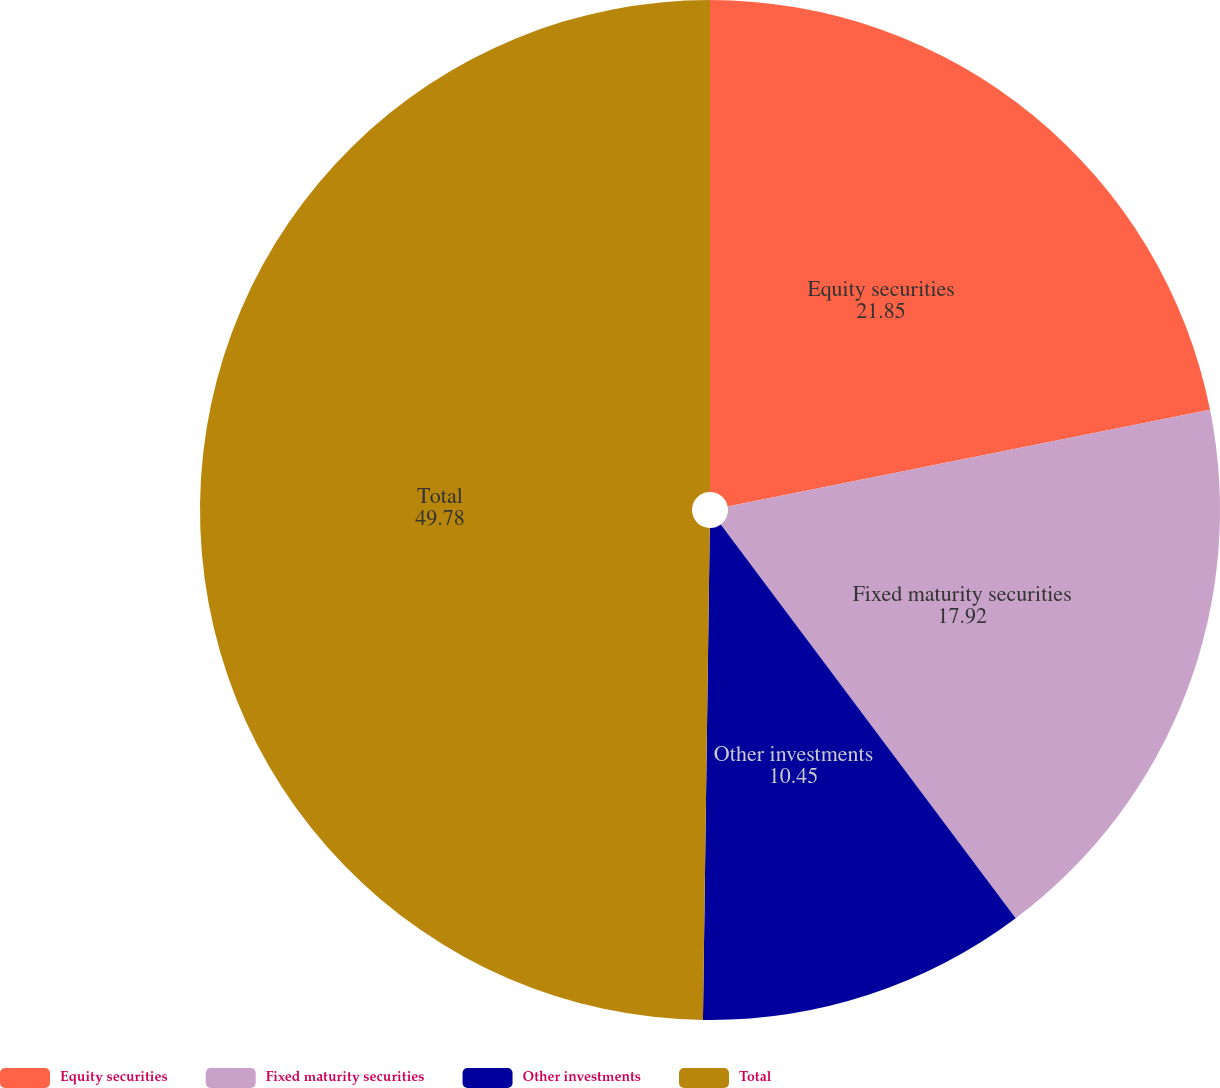Convert chart to OTSL. <chart><loc_0><loc_0><loc_500><loc_500><pie_chart><fcel>Equity securities<fcel>Fixed maturity securities<fcel>Other investments<fcel>Total<nl><fcel>21.85%<fcel>17.92%<fcel>10.45%<fcel>49.78%<nl></chart> 